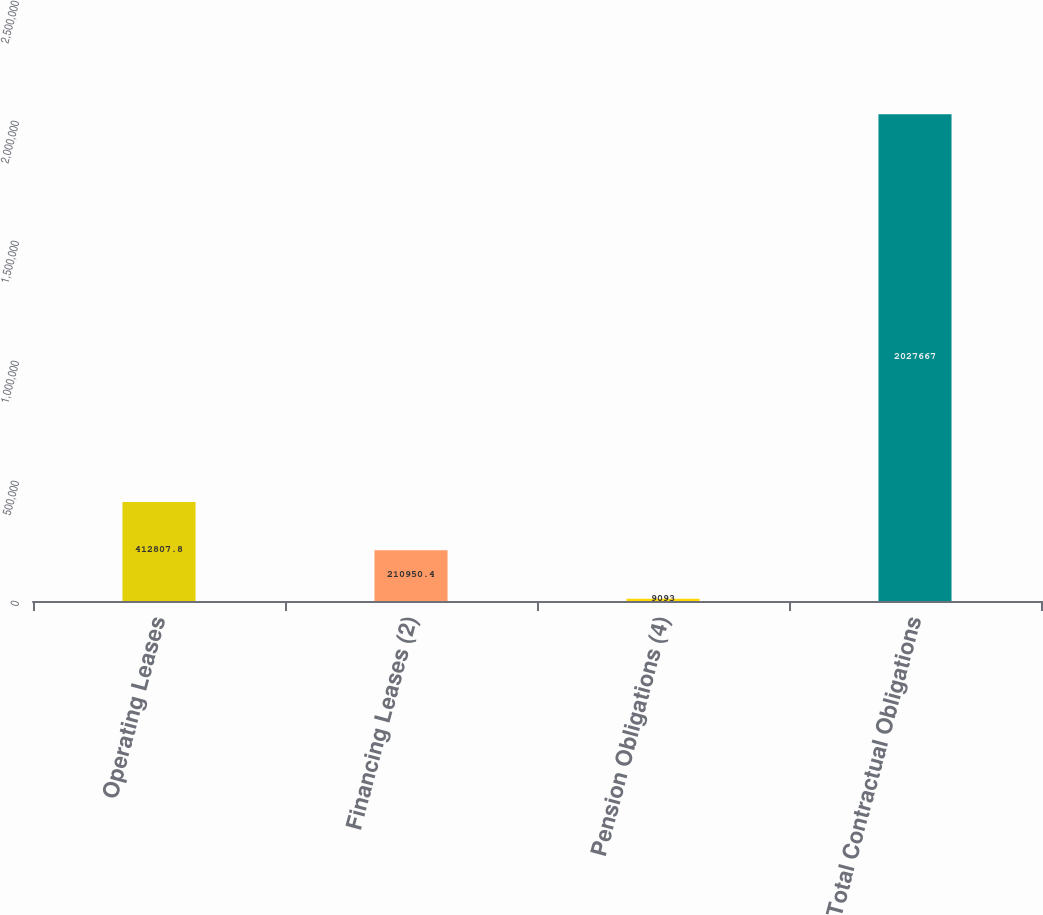Convert chart to OTSL. <chart><loc_0><loc_0><loc_500><loc_500><bar_chart><fcel>Operating Leases<fcel>Financing Leases (2)<fcel>Pension Obligations (4)<fcel>Total Contractual Obligations<nl><fcel>412808<fcel>210950<fcel>9093<fcel>2.02767e+06<nl></chart> 